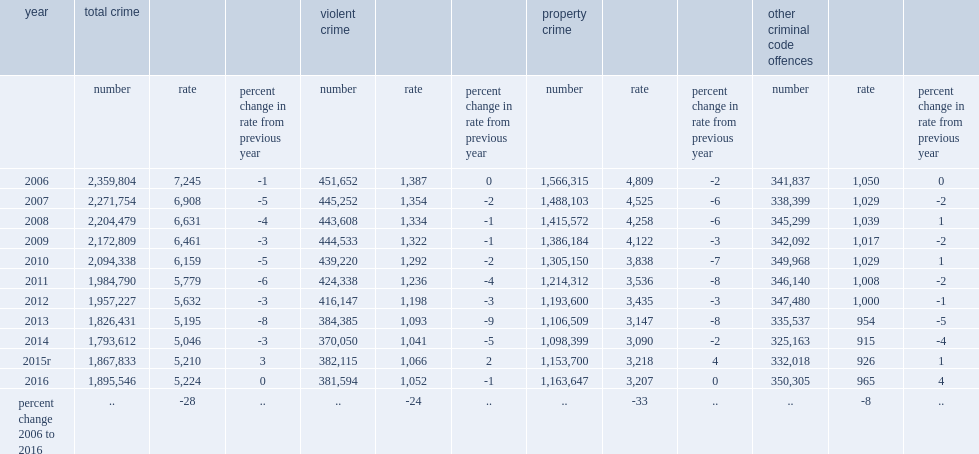What is the percentage of violent crimes account for all police-reported criminal code offences in 2016? 0.201311. How many police-reported violent incidents happened in 2016? 381594.0. Comparing to the previous year how many less police-reported violent incidents happened in 2016? 521. What is the violent incidents per 100,000 population in canada in 2016? 1052.0. Comparing to 2015, how many percentage point of the violent crime rate in canada has declined in 2016? 1. Comparing to a decade earlier, how much percentage point of the violent crime rate in canada has declined in 2016? 24. Which kind of crime was most reported by police in 2016? Property crime other criminal code offences. What is the percentage point of most crime reported by police was non-violent in nature accounting for police-reported criminal code incidents in 2016? 0.798689. How many police-reported non-violent criminal code incidents it has in 2016? 1513952. In total, there were over 1.2 million police-reported non-violent criminal code incidents in 2016 (excluding traffic)was accounting for property crimes. 1163647.0. What is the rate of property crime in 2015? 3218.0. What is the rate of property crime in 2016? 3207.0. 